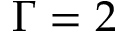Convert formula to latex. <formula><loc_0><loc_0><loc_500><loc_500>\Gamma = 2</formula> 